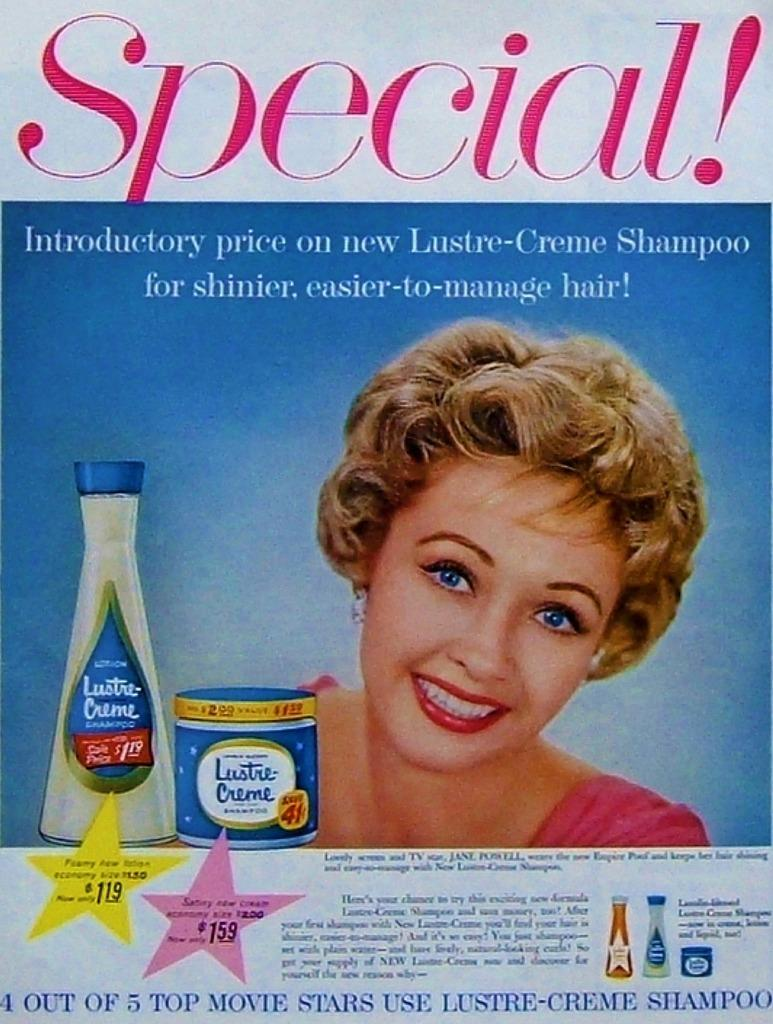What is present in the image that features a visual representation? There is a poster in the image. What can be seen in the picture on the poster? The poster contains a picture of a woman. What else is included on the poster besides the image? There is text on the poster. How many bananas are hanging from the picture of the woman on the poster? There are no bananas present in the image or on the poster. What type of note is attached to the bottom of the poster? There is no note attached to the bottom of the poster; only the picture of a woman and text are present. 